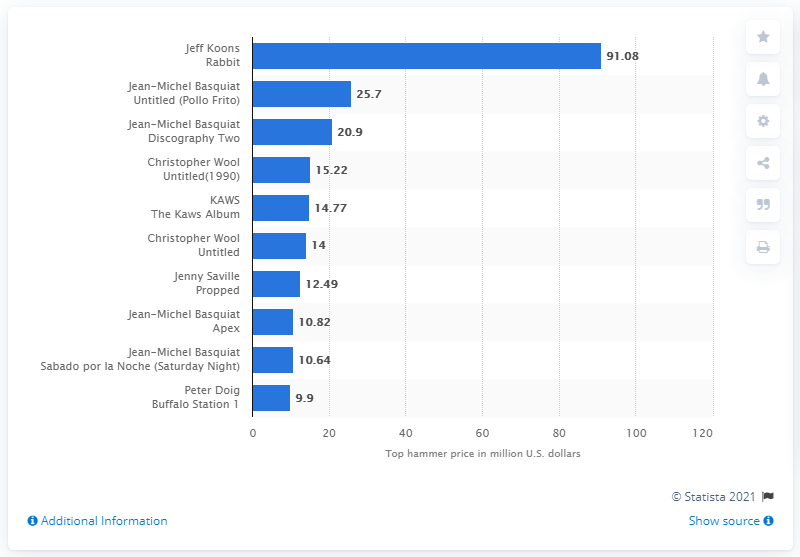Draw attention to some important aspects in this diagram. The hammer price for Jeff Koons' works in 2019 was $91.08. 